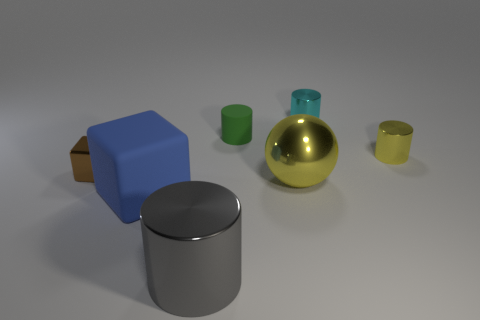Add 1 metallic balls. How many objects exist? 8 Subtract all cubes. How many objects are left? 5 Add 6 big blocks. How many big blocks are left? 7 Add 1 big yellow metallic spheres. How many big yellow metallic spheres exist? 2 Subtract 0 blue cylinders. How many objects are left? 7 Subtract all small cyan shiny cylinders. Subtract all purple metallic cubes. How many objects are left? 6 